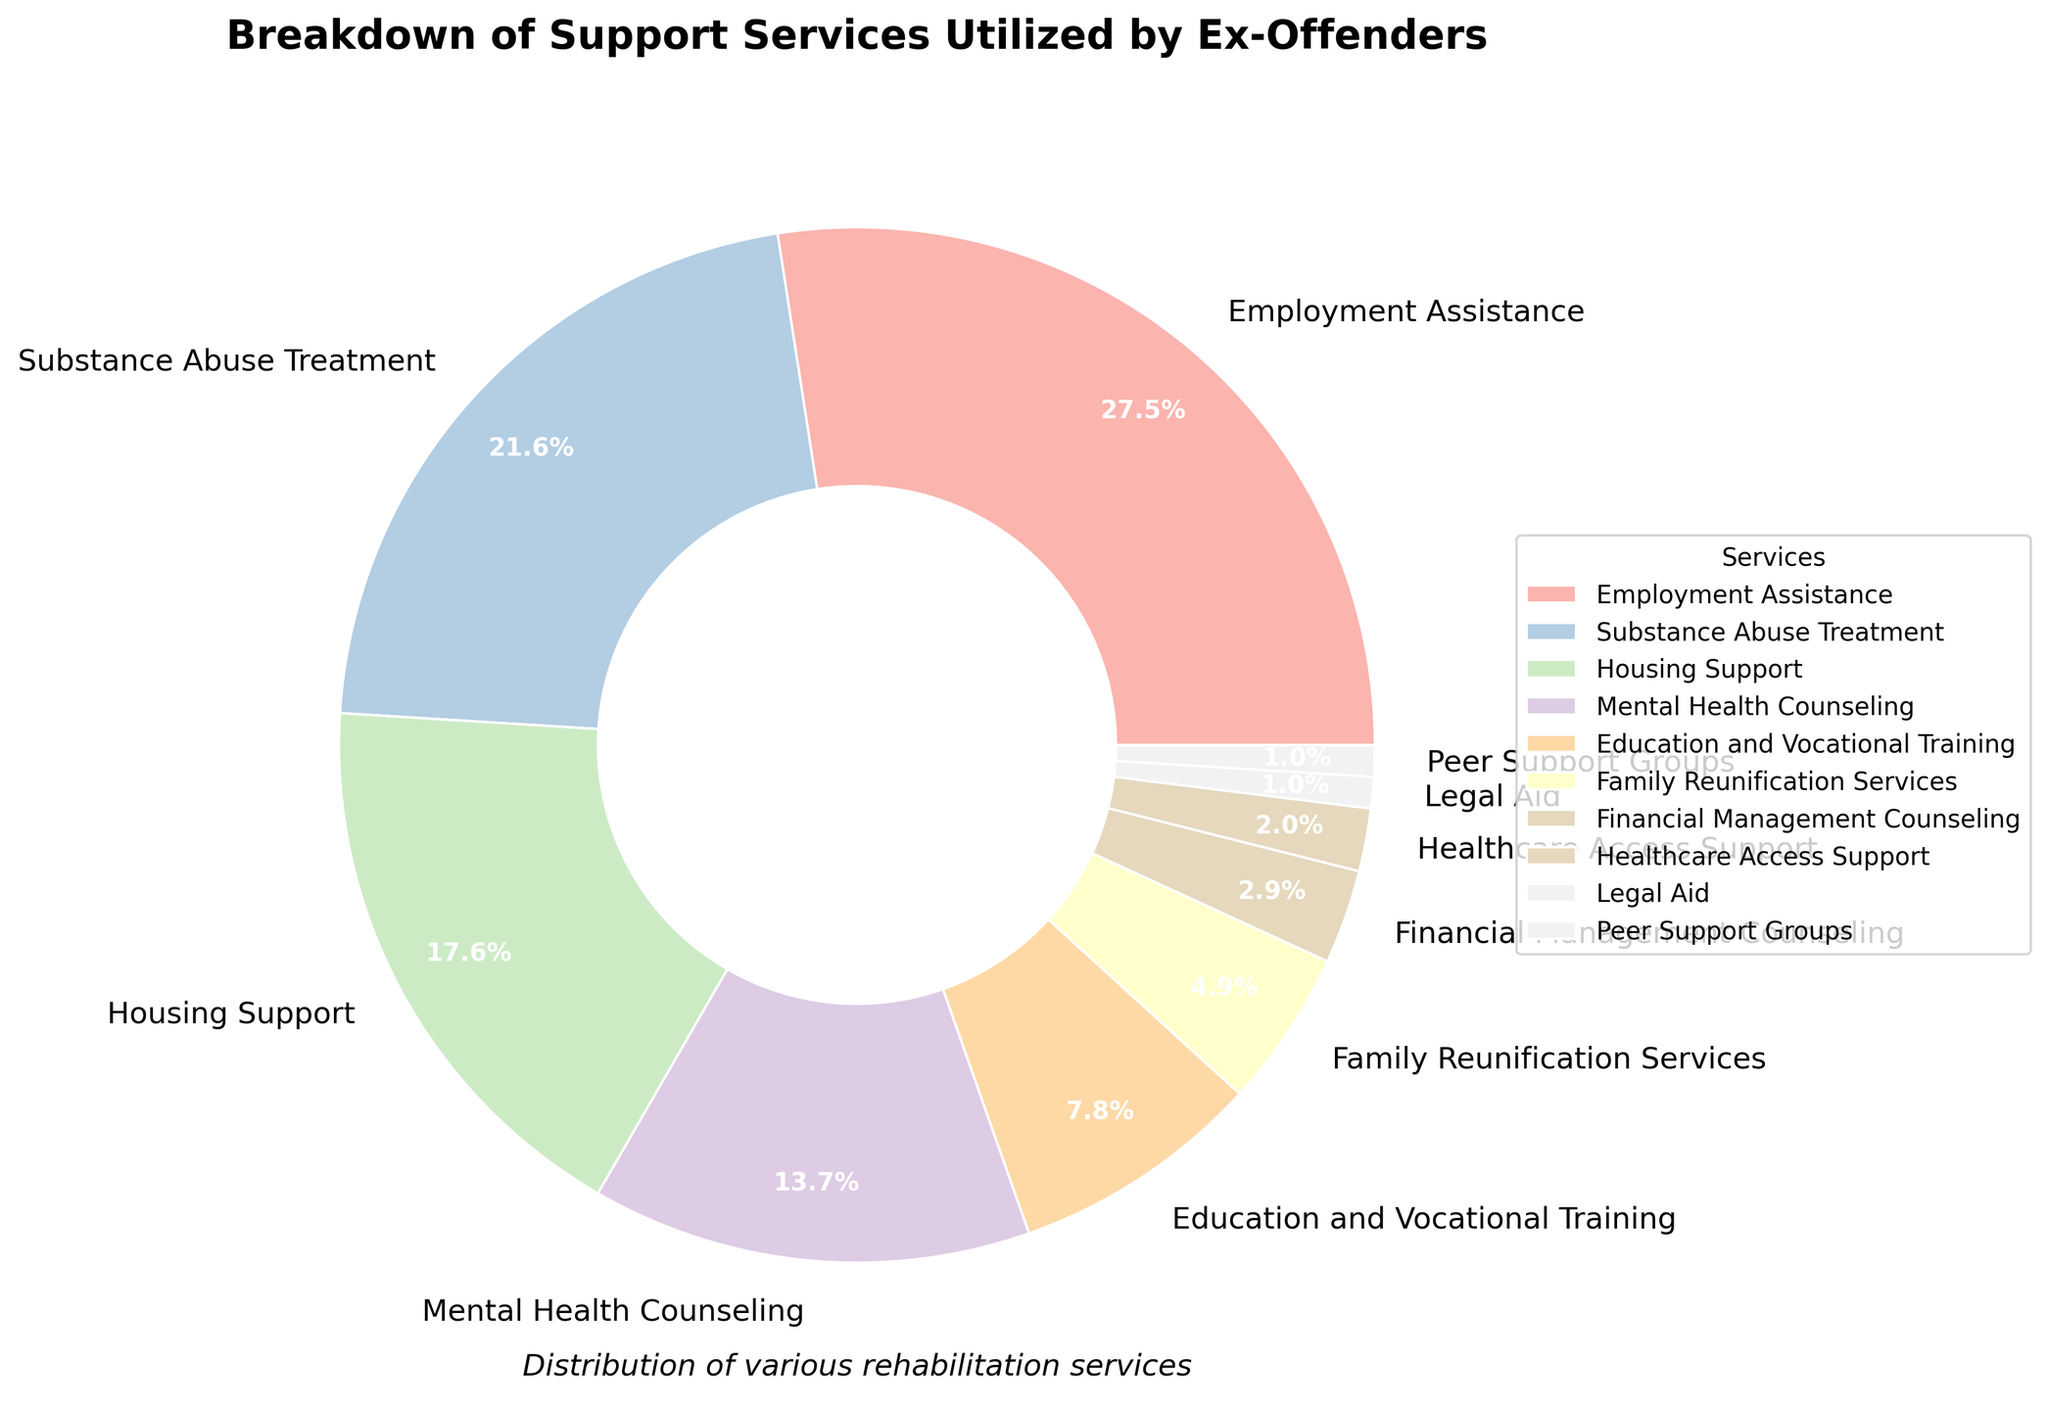What's the most utilized support service by ex-offenders? The pie chart shows various support services and their utilization percentages. The largest segment represents the most utilized service. Employment Assistance has the highest percentage at 28%.
Answer: Employment Assistance Which service has the lowest utilization among the provided options? The pie chart displays percentages for each service. The smallest segment corresponds to the least utilized service. Both Legal Aid and Peer Support Groups have the lowest utilization at 1%.
Answer: Legal Aid and Peer Support Groups How much more is the percentage of Employment Assistance than Substance Abuse Treatment? Employment Assistance is 28% and Substance Abuse Treatment is 22%. The difference is calculated as 28% - 22%.
Answer: 6% What is the combined percentage of services related to counseling (Mental Health Counseling and Substance Abuse Treatment)? Mental Health Counseling is 14% and Substance Abuse Treatment is 22%. Their combined percentage is 14% + 22%.
Answer: 36% What is the difference in utilization between Housing Support and Education and Vocational Training? Housing Support is 18% and Education and Vocational Training is 8%. The difference is calculated as 18% - 8%.
Answer: 10% How many times more is the percentage of Employment Assistance compared to Healthcare Access Support? Employment Assistance is 28% and Healthcare Access Support is 2%. The ratio is 28 divided by 2.
Answer: 14 times What is the total percentage of the top three most utilized services? The top three services by percentage are Employment Assistance (28%), Substance Abuse Treatment (22%), and Housing Support (18%). Their total percentage is 28% + 22% + 18%.
Answer: 68% Which service has a percentage closest to 10%? By looking at the pie chart, Education and Vocational Training has a percentage of 8%, which is closest to 10%.
Answer: Education and Vocational Training Compare the utilization of Family Reunification Services to Legal Aid and Peer Support Groups combined. Which has a higher percentage? Family Reunification Services is 5%. The combined percentage of Legal Aid (1%) and Peer Support Groups (1%) is 1% + 1% = 2%.
Answer: Family Reunification Services What is the percentage difference between Financial Management Counseling and Healthcare Access Support? Financial Management Counseling is 3% and Healthcare Access Support is 2%. The difference is 3% - 2%.
Answer: 1% 